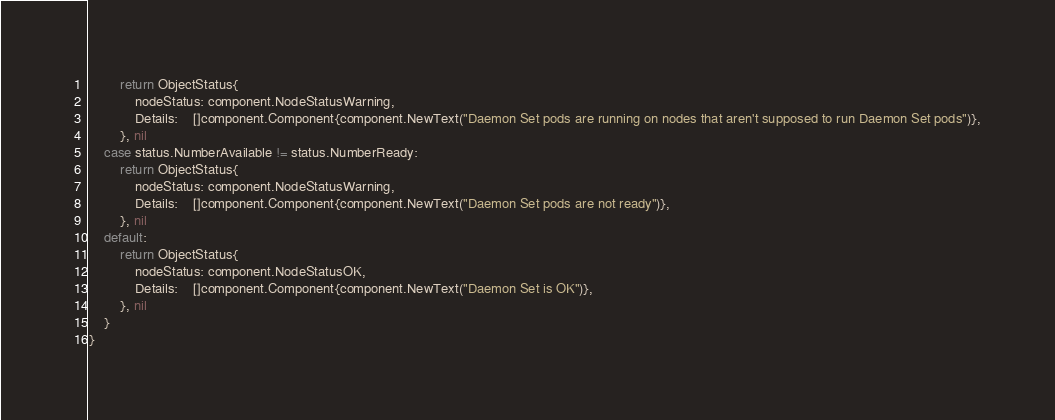Convert code to text. <code><loc_0><loc_0><loc_500><loc_500><_Go_>		return ObjectStatus{
			nodeStatus: component.NodeStatusWarning,
			Details:    []component.Component{component.NewText("Daemon Set pods are running on nodes that aren't supposed to run Daemon Set pods")},
		}, nil
	case status.NumberAvailable != status.NumberReady:
		return ObjectStatus{
			nodeStatus: component.NodeStatusWarning,
			Details:    []component.Component{component.NewText("Daemon Set pods are not ready")},
		}, nil
	default:
		return ObjectStatus{
			nodeStatus: component.NodeStatusOK,
			Details:    []component.Component{component.NewText("Daemon Set is OK")},
		}, nil
	}
}
</code> 